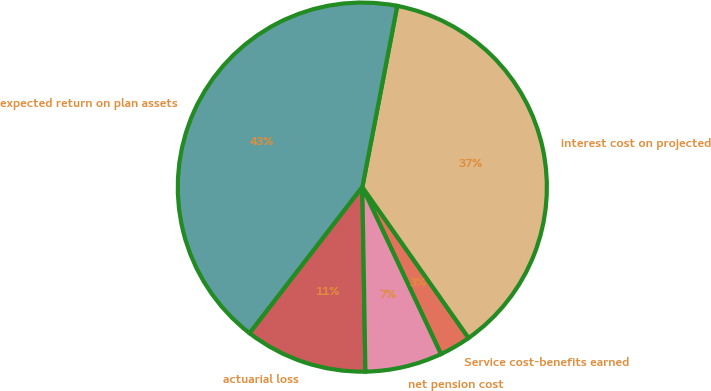Convert chart to OTSL. <chart><loc_0><loc_0><loc_500><loc_500><pie_chart><fcel>Service cost-benefits earned<fcel>interest cost on projected<fcel>expected return on plan assets<fcel>actuarial loss<fcel>net pension cost<nl><fcel>2.76%<fcel>37.2%<fcel>42.57%<fcel>10.72%<fcel>6.74%<nl></chart> 